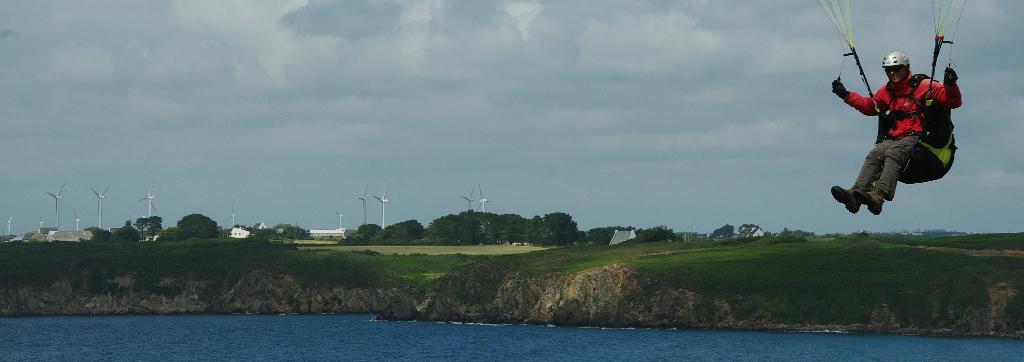Can you describe this image briefly? In the center of the image there is a man flying. In the background there is water, grass, trees, wind vanes, building, sky and clouds. 